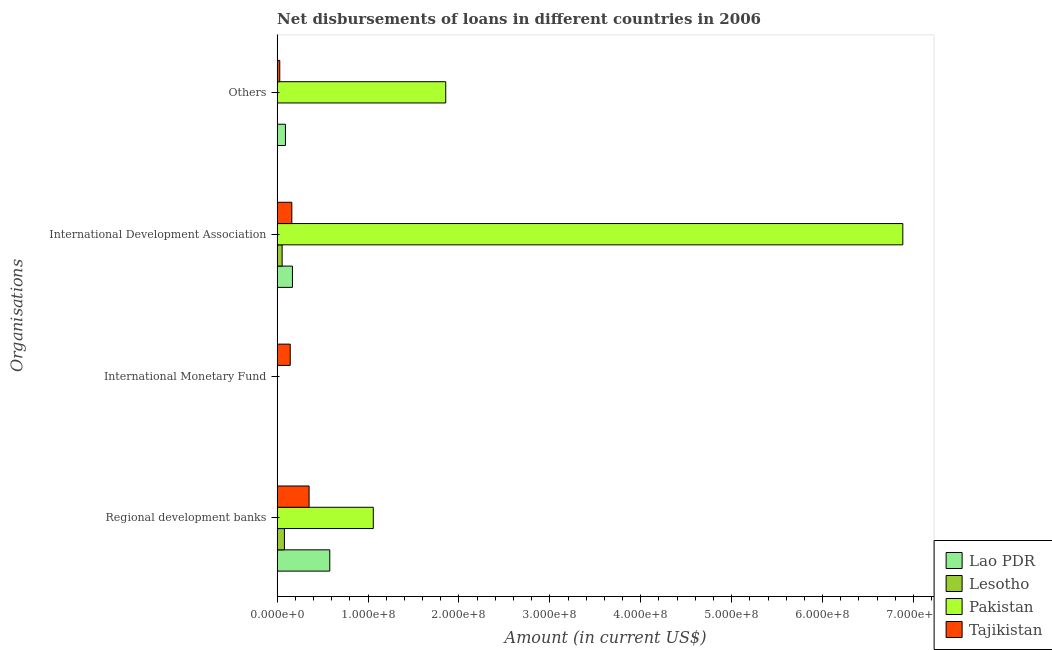How many different coloured bars are there?
Offer a very short reply. 4. Are the number of bars per tick equal to the number of legend labels?
Offer a terse response. No. Are the number of bars on each tick of the Y-axis equal?
Provide a succinct answer. No. What is the label of the 2nd group of bars from the top?
Keep it short and to the point. International Development Association. What is the amount of loan disimbursed by international monetary fund in Lesotho?
Ensure brevity in your answer.  0. Across all countries, what is the maximum amount of loan disimbursed by other organisations?
Give a very brief answer. 1.85e+08. In which country was the amount of loan disimbursed by international monetary fund maximum?
Offer a very short reply. Tajikistan. What is the total amount of loan disimbursed by other organisations in the graph?
Keep it short and to the point. 1.98e+08. What is the difference between the amount of loan disimbursed by regional development banks in Lesotho and that in Lao PDR?
Your response must be concise. -4.99e+07. What is the difference between the amount of loan disimbursed by international development association in Pakistan and the amount of loan disimbursed by regional development banks in Tajikistan?
Give a very brief answer. 6.53e+08. What is the average amount of loan disimbursed by international development association per country?
Provide a succinct answer. 1.82e+08. What is the difference between the amount of loan disimbursed by other organisations and amount of loan disimbursed by regional development banks in Tajikistan?
Make the answer very short. -3.23e+07. In how many countries, is the amount of loan disimbursed by regional development banks greater than 620000000 US$?
Ensure brevity in your answer.  0. What is the ratio of the amount of loan disimbursed by regional development banks in Lesotho to that in Lao PDR?
Make the answer very short. 0.14. Is the amount of loan disimbursed by regional development banks in Lao PDR less than that in Lesotho?
Offer a terse response. No. What is the difference between the highest and the second highest amount of loan disimbursed by international development association?
Make the answer very short. 6.71e+08. What is the difference between the highest and the lowest amount of loan disimbursed by regional development banks?
Offer a terse response. 9.78e+07. In how many countries, is the amount of loan disimbursed by international monetary fund greater than the average amount of loan disimbursed by international monetary fund taken over all countries?
Make the answer very short. 1. Is it the case that in every country, the sum of the amount of loan disimbursed by regional development banks and amount of loan disimbursed by international monetary fund is greater than the sum of amount of loan disimbursed by international development association and amount of loan disimbursed by other organisations?
Give a very brief answer. No. Is it the case that in every country, the sum of the amount of loan disimbursed by regional development banks and amount of loan disimbursed by international monetary fund is greater than the amount of loan disimbursed by international development association?
Your response must be concise. No. How many bars are there?
Offer a terse response. 12. Are all the bars in the graph horizontal?
Keep it short and to the point. Yes. How many legend labels are there?
Keep it short and to the point. 4. How are the legend labels stacked?
Offer a terse response. Vertical. What is the title of the graph?
Your answer should be compact. Net disbursements of loans in different countries in 2006. What is the label or title of the X-axis?
Offer a very short reply. Amount (in current US$). What is the label or title of the Y-axis?
Your answer should be very brief. Organisations. What is the Amount (in current US$) of Lao PDR in Regional development banks?
Provide a short and direct response. 5.79e+07. What is the Amount (in current US$) of Lesotho in Regional development banks?
Your answer should be compact. 8.02e+06. What is the Amount (in current US$) of Pakistan in Regional development banks?
Make the answer very short. 1.06e+08. What is the Amount (in current US$) in Tajikistan in Regional development banks?
Ensure brevity in your answer.  3.52e+07. What is the Amount (in current US$) in Lao PDR in International Monetary Fund?
Offer a very short reply. 0. What is the Amount (in current US$) of Lesotho in International Monetary Fund?
Your answer should be compact. 0. What is the Amount (in current US$) of Pakistan in International Monetary Fund?
Make the answer very short. 0. What is the Amount (in current US$) in Tajikistan in International Monetary Fund?
Provide a succinct answer. 1.44e+07. What is the Amount (in current US$) of Lao PDR in International Development Association?
Your answer should be compact. 1.69e+07. What is the Amount (in current US$) in Lesotho in International Development Association?
Give a very brief answer. 5.51e+06. What is the Amount (in current US$) in Pakistan in International Development Association?
Make the answer very short. 6.88e+08. What is the Amount (in current US$) of Tajikistan in International Development Association?
Offer a very short reply. 1.62e+07. What is the Amount (in current US$) in Lao PDR in Others?
Your answer should be compact. 9.16e+06. What is the Amount (in current US$) in Pakistan in Others?
Keep it short and to the point. 1.85e+08. What is the Amount (in current US$) in Tajikistan in Others?
Provide a short and direct response. 2.91e+06. Across all Organisations, what is the maximum Amount (in current US$) of Lao PDR?
Provide a short and direct response. 5.79e+07. Across all Organisations, what is the maximum Amount (in current US$) of Lesotho?
Your answer should be compact. 8.02e+06. Across all Organisations, what is the maximum Amount (in current US$) of Pakistan?
Make the answer very short. 6.88e+08. Across all Organisations, what is the maximum Amount (in current US$) of Tajikistan?
Offer a very short reply. 3.52e+07. Across all Organisations, what is the minimum Amount (in current US$) of Lao PDR?
Offer a terse response. 0. Across all Organisations, what is the minimum Amount (in current US$) in Lesotho?
Provide a short and direct response. 0. Across all Organisations, what is the minimum Amount (in current US$) of Tajikistan?
Your answer should be very brief. 2.91e+06. What is the total Amount (in current US$) of Lao PDR in the graph?
Your response must be concise. 8.40e+07. What is the total Amount (in current US$) of Lesotho in the graph?
Give a very brief answer. 1.35e+07. What is the total Amount (in current US$) of Pakistan in the graph?
Provide a succinct answer. 9.80e+08. What is the total Amount (in current US$) in Tajikistan in the graph?
Your answer should be compact. 6.87e+07. What is the difference between the Amount (in current US$) in Tajikistan in Regional development banks and that in International Monetary Fund?
Your answer should be very brief. 2.07e+07. What is the difference between the Amount (in current US$) of Lao PDR in Regional development banks and that in International Development Association?
Make the answer very short. 4.11e+07. What is the difference between the Amount (in current US$) of Lesotho in Regional development banks and that in International Development Association?
Offer a very short reply. 2.51e+06. What is the difference between the Amount (in current US$) of Pakistan in Regional development banks and that in International Development Association?
Offer a very short reply. -5.82e+08. What is the difference between the Amount (in current US$) in Tajikistan in Regional development banks and that in International Development Association?
Offer a terse response. 1.90e+07. What is the difference between the Amount (in current US$) in Lao PDR in Regional development banks and that in Others?
Keep it short and to the point. 4.88e+07. What is the difference between the Amount (in current US$) in Pakistan in Regional development banks and that in Others?
Offer a terse response. -7.97e+07. What is the difference between the Amount (in current US$) in Tajikistan in Regional development banks and that in Others?
Offer a terse response. 3.23e+07. What is the difference between the Amount (in current US$) of Tajikistan in International Monetary Fund and that in International Development Association?
Provide a short and direct response. -1.75e+06. What is the difference between the Amount (in current US$) of Tajikistan in International Monetary Fund and that in Others?
Give a very brief answer. 1.15e+07. What is the difference between the Amount (in current US$) of Lao PDR in International Development Association and that in Others?
Your answer should be very brief. 7.70e+06. What is the difference between the Amount (in current US$) of Pakistan in International Development Association and that in Others?
Give a very brief answer. 5.03e+08. What is the difference between the Amount (in current US$) of Tajikistan in International Development Association and that in Others?
Make the answer very short. 1.33e+07. What is the difference between the Amount (in current US$) in Lao PDR in Regional development banks and the Amount (in current US$) in Tajikistan in International Monetary Fund?
Your answer should be very brief. 4.35e+07. What is the difference between the Amount (in current US$) of Lesotho in Regional development banks and the Amount (in current US$) of Tajikistan in International Monetary Fund?
Offer a very short reply. -6.40e+06. What is the difference between the Amount (in current US$) in Pakistan in Regional development banks and the Amount (in current US$) in Tajikistan in International Monetary Fund?
Give a very brief answer. 9.14e+07. What is the difference between the Amount (in current US$) in Lao PDR in Regional development banks and the Amount (in current US$) in Lesotho in International Development Association?
Provide a succinct answer. 5.24e+07. What is the difference between the Amount (in current US$) of Lao PDR in Regional development banks and the Amount (in current US$) of Pakistan in International Development Association?
Offer a terse response. -6.30e+08. What is the difference between the Amount (in current US$) in Lao PDR in Regional development banks and the Amount (in current US$) in Tajikistan in International Development Association?
Your answer should be very brief. 4.18e+07. What is the difference between the Amount (in current US$) in Lesotho in Regional development banks and the Amount (in current US$) in Pakistan in International Development Association?
Your answer should be very brief. -6.80e+08. What is the difference between the Amount (in current US$) of Lesotho in Regional development banks and the Amount (in current US$) of Tajikistan in International Development Association?
Make the answer very short. -8.15e+06. What is the difference between the Amount (in current US$) in Pakistan in Regional development banks and the Amount (in current US$) in Tajikistan in International Development Association?
Offer a very short reply. 8.96e+07. What is the difference between the Amount (in current US$) in Lao PDR in Regional development banks and the Amount (in current US$) in Pakistan in Others?
Provide a short and direct response. -1.28e+08. What is the difference between the Amount (in current US$) of Lao PDR in Regional development banks and the Amount (in current US$) of Tajikistan in Others?
Provide a succinct answer. 5.50e+07. What is the difference between the Amount (in current US$) of Lesotho in Regional development banks and the Amount (in current US$) of Pakistan in Others?
Ensure brevity in your answer.  -1.77e+08. What is the difference between the Amount (in current US$) in Lesotho in Regional development banks and the Amount (in current US$) in Tajikistan in Others?
Give a very brief answer. 5.11e+06. What is the difference between the Amount (in current US$) of Pakistan in Regional development banks and the Amount (in current US$) of Tajikistan in Others?
Give a very brief answer. 1.03e+08. What is the difference between the Amount (in current US$) of Lao PDR in International Development Association and the Amount (in current US$) of Pakistan in Others?
Offer a very short reply. -1.69e+08. What is the difference between the Amount (in current US$) of Lao PDR in International Development Association and the Amount (in current US$) of Tajikistan in Others?
Provide a succinct answer. 1.39e+07. What is the difference between the Amount (in current US$) in Lesotho in International Development Association and the Amount (in current US$) in Pakistan in Others?
Make the answer very short. -1.80e+08. What is the difference between the Amount (in current US$) of Lesotho in International Development Association and the Amount (in current US$) of Tajikistan in Others?
Make the answer very short. 2.60e+06. What is the difference between the Amount (in current US$) in Pakistan in International Development Association and the Amount (in current US$) in Tajikistan in Others?
Offer a terse response. 6.85e+08. What is the average Amount (in current US$) of Lao PDR per Organisations?
Keep it short and to the point. 2.10e+07. What is the average Amount (in current US$) in Lesotho per Organisations?
Ensure brevity in your answer.  3.38e+06. What is the average Amount (in current US$) of Pakistan per Organisations?
Provide a succinct answer. 2.45e+08. What is the average Amount (in current US$) of Tajikistan per Organisations?
Your answer should be very brief. 1.72e+07. What is the difference between the Amount (in current US$) in Lao PDR and Amount (in current US$) in Lesotho in Regional development banks?
Your response must be concise. 4.99e+07. What is the difference between the Amount (in current US$) in Lao PDR and Amount (in current US$) in Pakistan in Regional development banks?
Your response must be concise. -4.79e+07. What is the difference between the Amount (in current US$) of Lao PDR and Amount (in current US$) of Tajikistan in Regional development banks?
Offer a very short reply. 2.28e+07. What is the difference between the Amount (in current US$) in Lesotho and Amount (in current US$) in Pakistan in Regional development banks?
Your answer should be very brief. -9.78e+07. What is the difference between the Amount (in current US$) in Lesotho and Amount (in current US$) in Tajikistan in Regional development banks?
Your answer should be very brief. -2.71e+07. What is the difference between the Amount (in current US$) in Pakistan and Amount (in current US$) in Tajikistan in Regional development banks?
Offer a terse response. 7.06e+07. What is the difference between the Amount (in current US$) of Lao PDR and Amount (in current US$) of Lesotho in International Development Association?
Provide a short and direct response. 1.14e+07. What is the difference between the Amount (in current US$) in Lao PDR and Amount (in current US$) in Pakistan in International Development Association?
Provide a succinct answer. -6.71e+08. What is the difference between the Amount (in current US$) of Lao PDR and Amount (in current US$) of Tajikistan in International Development Association?
Provide a succinct answer. 6.86e+05. What is the difference between the Amount (in current US$) of Lesotho and Amount (in current US$) of Pakistan in International Development Association?
Your answer should be compact. -6.83e+08. What is the difference between the Amount (in current US$) in Lesotho and Amount (in current US$) in Tajikistan in International Development Association?
Provide a succinct answer. -1.07e+07. What is the difference between the Amount (in current US$) in Pakistan and Amount (in current US$) in Tajikistan in International Development Association?
Give a very brief answer. 6.72e+08. What is the difference between the Amount (in current US$) in Lao PDR and Amount (in current US$) in Pakistan in Others?
Offer a terse response. -1.76e+08. What is the difference between the Amount (in current US$) of Lao PDR and Amount (in current US$) of Tajikistan in Others?
Offer a very short reply. 6.25e+06. What is the difference between the Amount (in current US$) of Pakistan and Amount (in current US$) of Tajikistan in Others?
Make the answer very short. 1.83e+08. What is the ratio of the Amount (in current US$) in Tajikistan in Regional development banks to that in International Monetary Fund?
Provide a short and direct response. 2.44. What is the ratio of the Amount (in current US$) of Lao PDR in Regional development banks to that in International Development Association?
Offer a very short reply. 3.44. What is the ratio of the Amount (in current US$) in Lesotho in Regional development banks to that in International Development Association?
Ensure brevity in your answer.  1.46. What is the ratio of the Amount (in current US$) in Pakistan in Regional development banks to that in International Development Association?
Offer a terse response. 0.15. What is the ratio of the Amount (in current US$) in Tajikistan in Regional development banks to that in International Development Association?
Give a very brief answer. 2.17. What is the ratio of the Amount (in current US$) of Lao PDR in Regional development banks to that in Others?
Your answer should be very brief. 6.32. What is the ratio of the Amount (in current US$) of Pakistan in Regional development banks to that in Others?
Your answer should be very brief. 0.57. What is the ratio of the Amount (in current US$) in Tajikistan in Regional development banks to that in Others?
Make the answer very short. 12.08. What is the ratio of the Amount (in current US$) in Tajikistan in International Monetary Fund to that in International Development Association?
Your answer should be very brief. 0.89. What is the ratio of the Amount (in current US$) of Tajikistan in International Monetary Fund to that in Others?
Provide a short and direct response. 4.95. What is the ratio of the Amount (in current US$) in Lao PDR in International Development Association to that in Others?
Offer a terse response. 1.84. What is the ratio of the Amount (in current US$) in Pakistan in International Development Association to that in Others?
Ensure brevity in your answer.  3.71. What is the ratio of the Amount (in current US$) in Tajikistan in International Development Association to that in Others?
Your answer should be very brief. 5.55. What is the difference between the highest and the second highest Amount (in current US$) in Lao PDR?
Make the answer very short. 4.11e+07. What is the difference between the highest and the second highest Amount (in current US$) in Pakistan?
Ensure brevity in your answer.  5.03e+08. What is the difference between the highest and the second highest Amount (in current US$) in Tajikistan?
Provide a short and direct response. 1.90e+07. What is the difference between the highest and the lowest Amount (in current US$) of Lao PDR?
Your response must be concise. 5.79e+07. What is the difference between the highest and the lowest Amount (in current US$) of Lesotho?
Provide a short and direct response. 8.02e+06. What is the difference between the highest and the lowest Amount (in current US$) of Pakistan?
Your response must be concise. 6.88e+08. What is the difference between the highest and the lowest Amount (in current US$) in Tajikistan?
Your answer should be compact. 3.23e+07. 